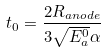<formula> <loc_0><loc_0><loc_500><loc_500>t _ { 0 } = \frac { 2 R _ { a n o d e } } { 3 \sqrt { E _ { a } ^ { 0 } } \alpha }</formula> 